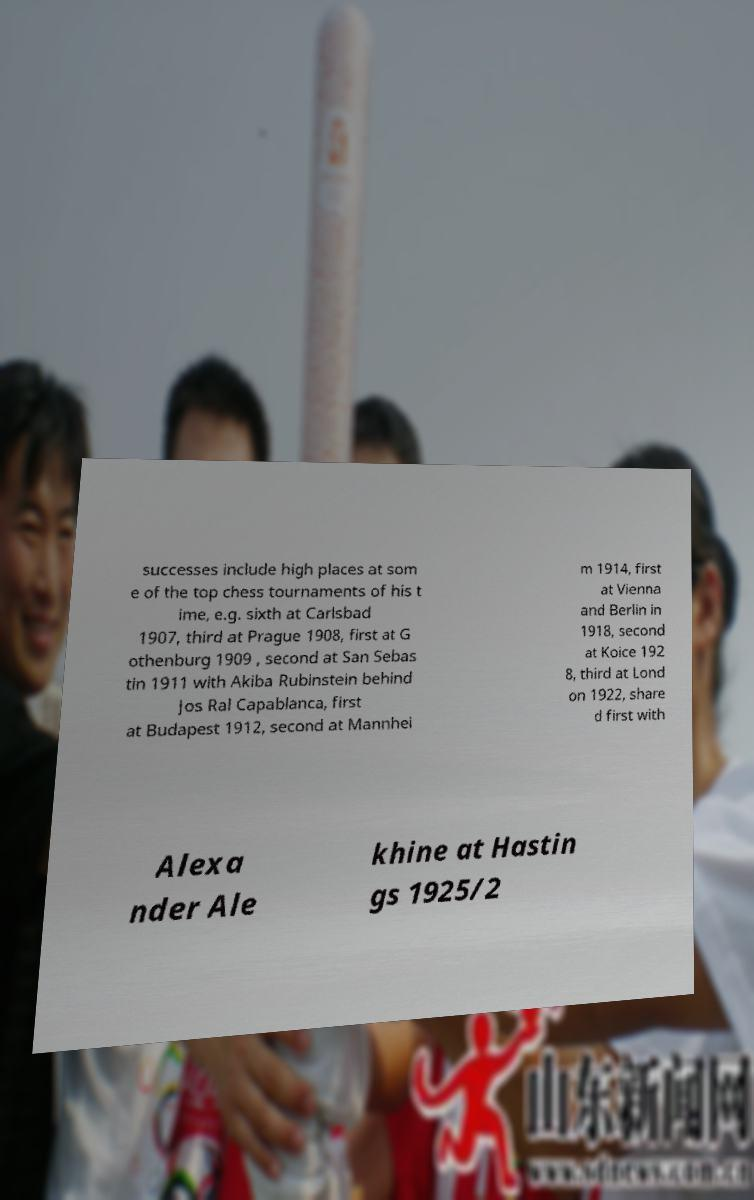Can you read and provide the text displayed in the image?This photo seems to have some interesting text. Can you extract and type it out for me? successes include high places at som e of the top chess tournaments of his t ime, e.g. sixth at Carlsbad 1907, third at Prague 1908, first at G othenburg 1909 , second at San Sebas tin 1911 with Akiba Rubinstein behind Jos Ral Capablanca, first at Budapest 1912, second at Mannhei m 1914, first at Vienna and Berlin in 1918, second at Koice 192 8, third at Lond on 1922, share d first with Alexa nder Ale khine at Hastin gs 1925/2 